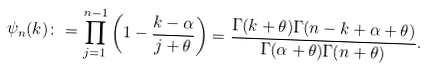Convert formula to latex. <formula><loc_0><loc_0><loc_500><loc_500>\psi _ { n } ( k ) \colon & = \prod _ { j = 1 } ^ { n - 1 } \left ( 1 - \frac { k - \alpha } { j + \theta } \right ) = \frac { \Gamma ( k + \theta ) \Gamma ( n - k + \alpha + \theta ) } { \Gamma ( \alpha + \theta ) \Gamma ( n + \theta ) } .</formula> 